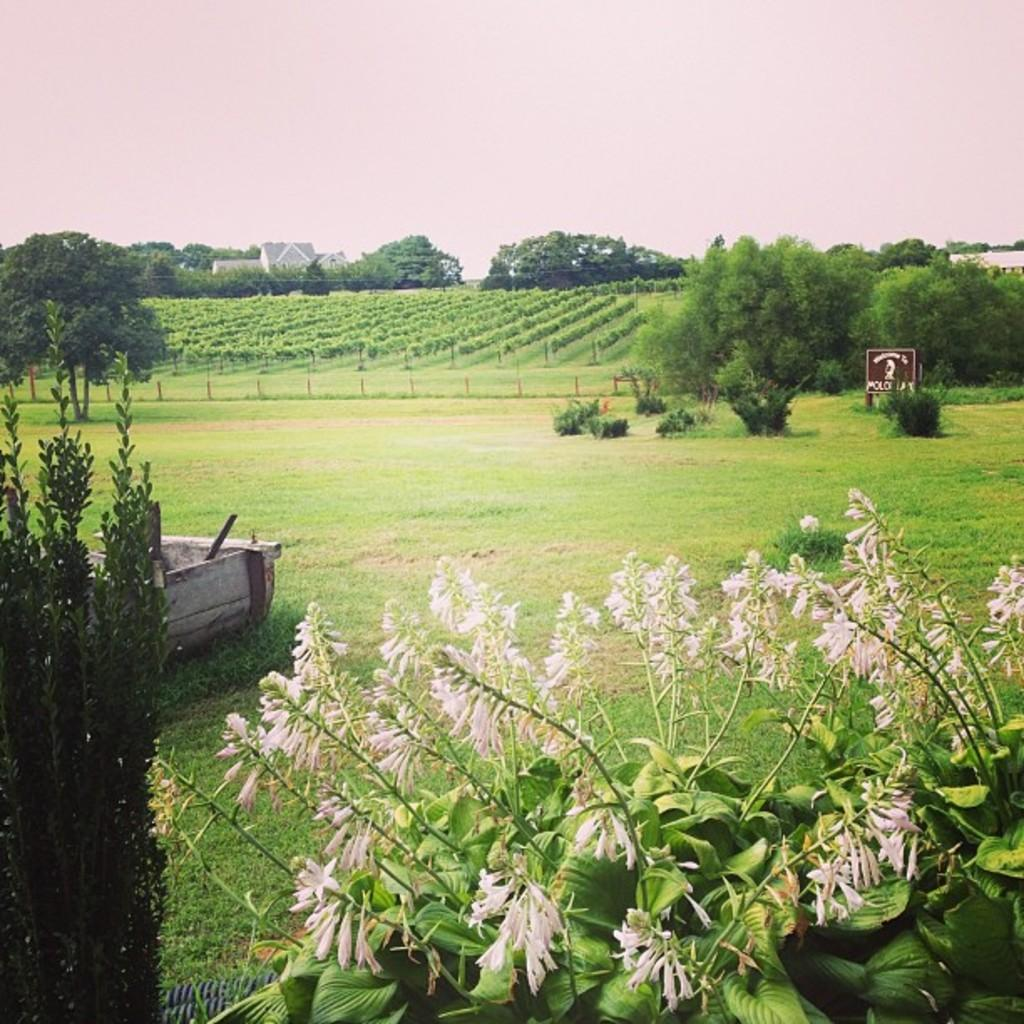What can be seen in the center of the image? The sky is visible in the center of the image. What type of natural elements are present in the image? There are trees, plants, grass, and flowers visible in the image. What type of man-made structures can be seen in the image? There is at least one building and a sign board present in the image. What type of enclosure is present in the image? Fences are present in the image. What is the wooden object in the image? There is a wooden object in the image, but its specific purpose or appearance is not mentioned in the facts. What other objects can be seen in the image? There are other objects in the image, but their specific details are not mentioned in the facts. What type of property does the partner own in the image? There is no mention of a partner or property ownership in the image. What notes are being taken in the notebook in the image? There is no notebook present in the image. 